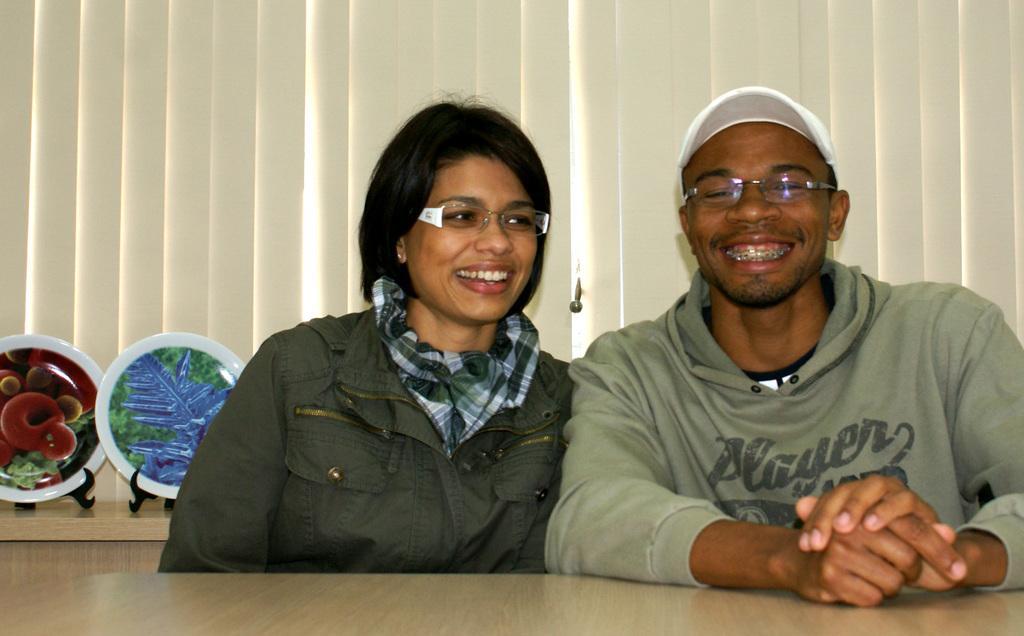In one or two sentences, can you explain what this image depicts? In the picture we can see a man and a woman sitting on the chairs near the desk, they are smiling and in the background, we can see a wooden wall on it, we can see some rats are placed and behind it we can see a curtain. 